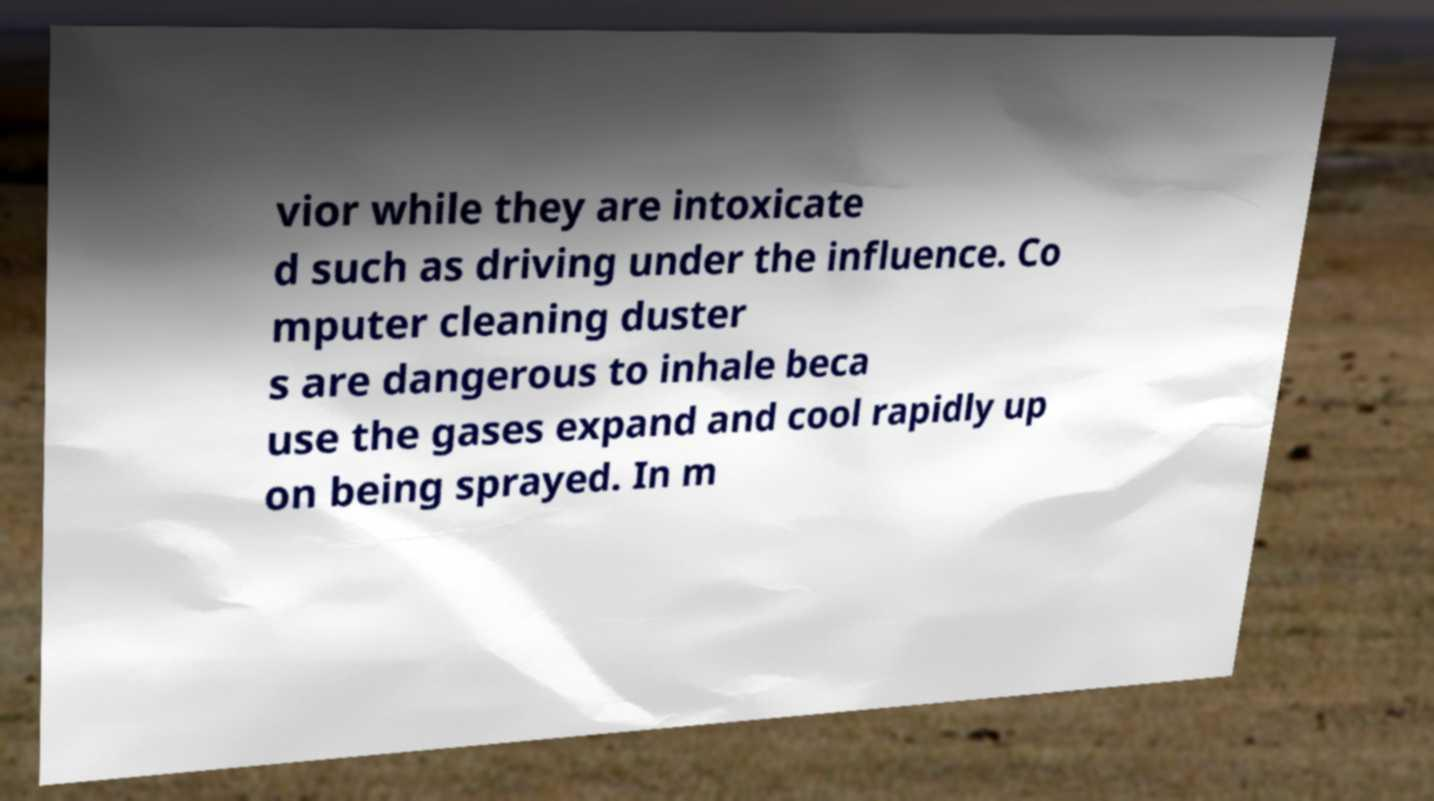What messages or text are displayed in this image? I need them in a readable, typed format. vior while they are intoxicate d such as driving under the influence. Co mputer cleaning duster s are dangerous to inhale beca use the gases expand and cool rapidly up on being sprayed. In m 